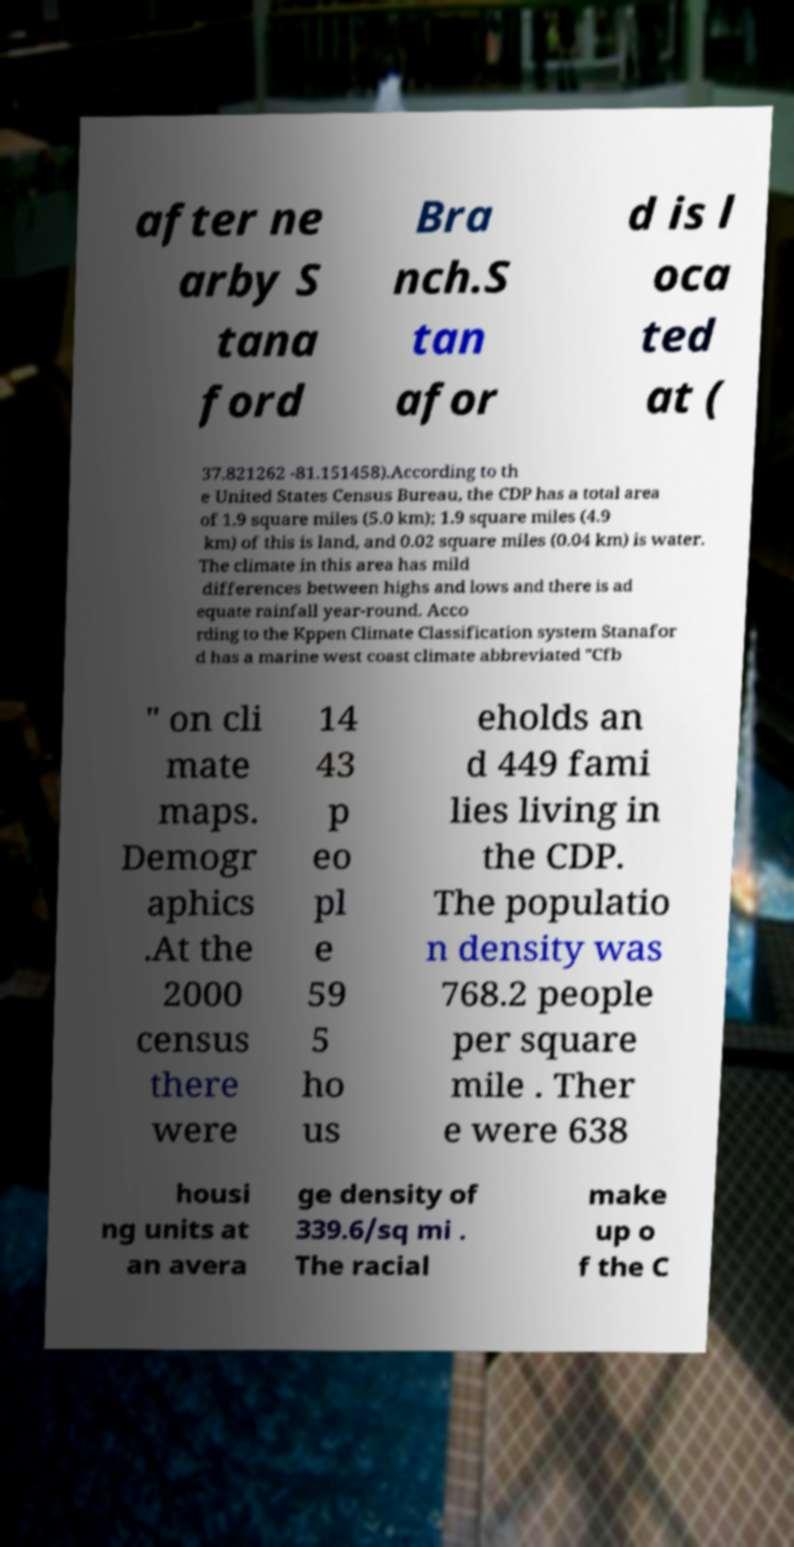Please identify and transcribe the text found in this image. after ne arby S tana ford Bra nch.S tan afor d is l oca ted at ( 37.821262 -81.151458).According to th e United States Census Bureau, the CDP has a total area of 1.9 square miles (5.0 km); 1.9 square miles (4.9 km) of this is land, and 0.02 square miles (0.04 km) is water. The climate in this area has mild differences between highs and lows and there is ad equate rainfall year-round. Acco rding to the Kppen Climate Classification system Stanafor d has a marine west coast climate abbreviated "Cfb " on cli mate maps. Demogr aphics .At the 2000 census there were 14 43 p eo pl e 59 5 ho us eholds an d 449 fami lies living in the CDP. The populatio n density was 768.2 people per square mile . Ther e were 638 housi ng units at an avera ge density of 339.6/sq mi . The racial make up o f the C 